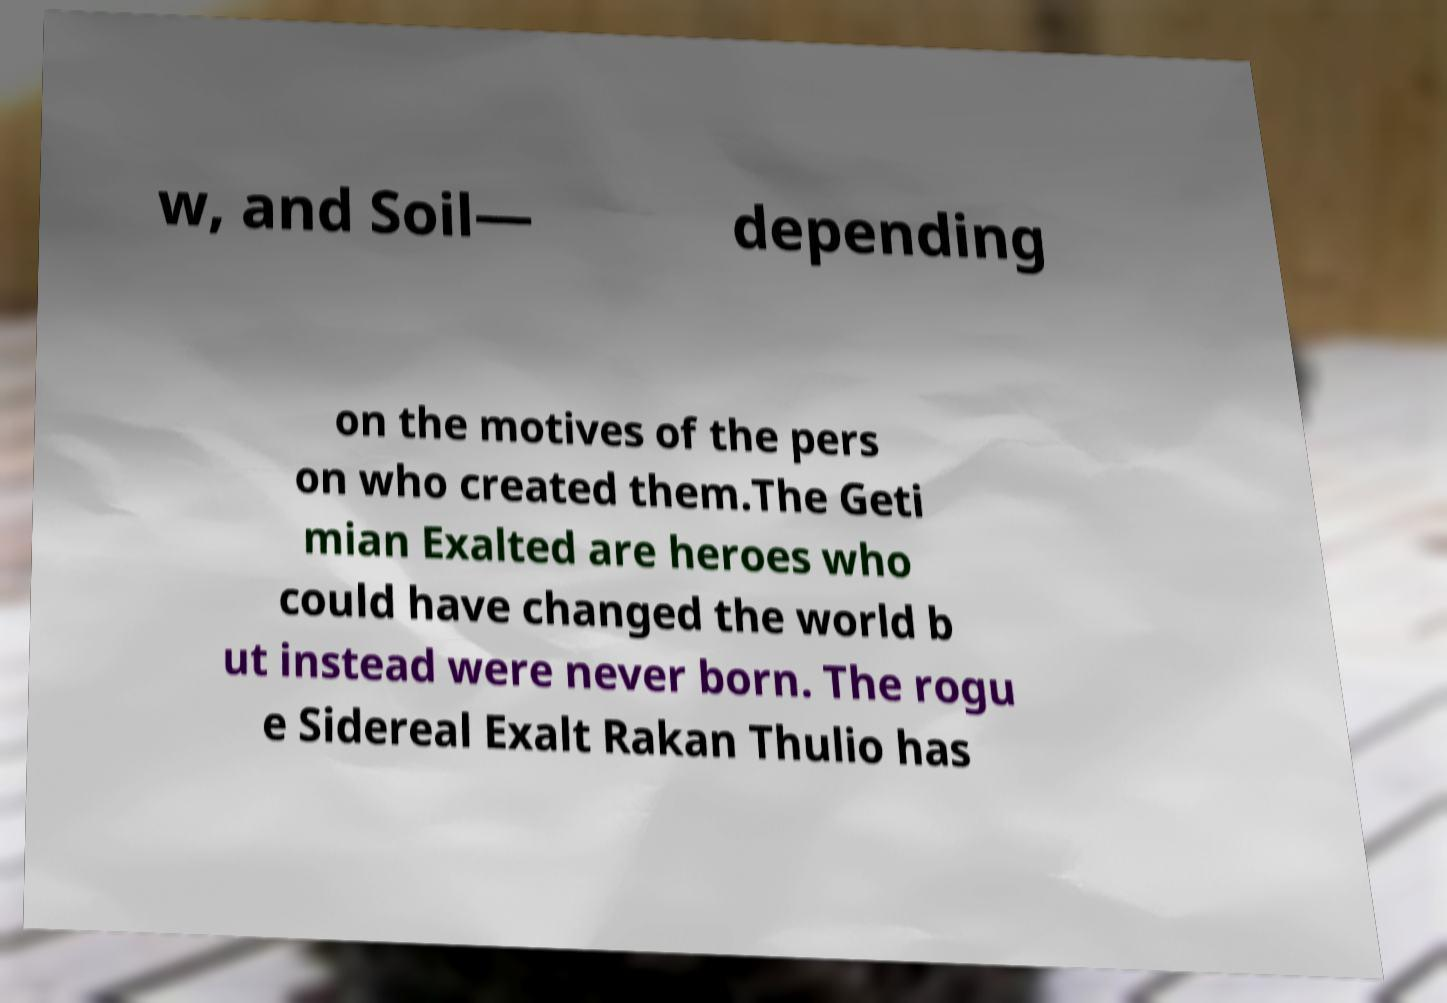Could you assist in decoding the text presented in this image and type it out clearly? w, and Soil— depending on the motives of the pers on who created them.The Geti mian Exalted are heroes who could have changed the world b ut instead were never born. The rogu e Sidereal Exalt Rakan Thulio has 